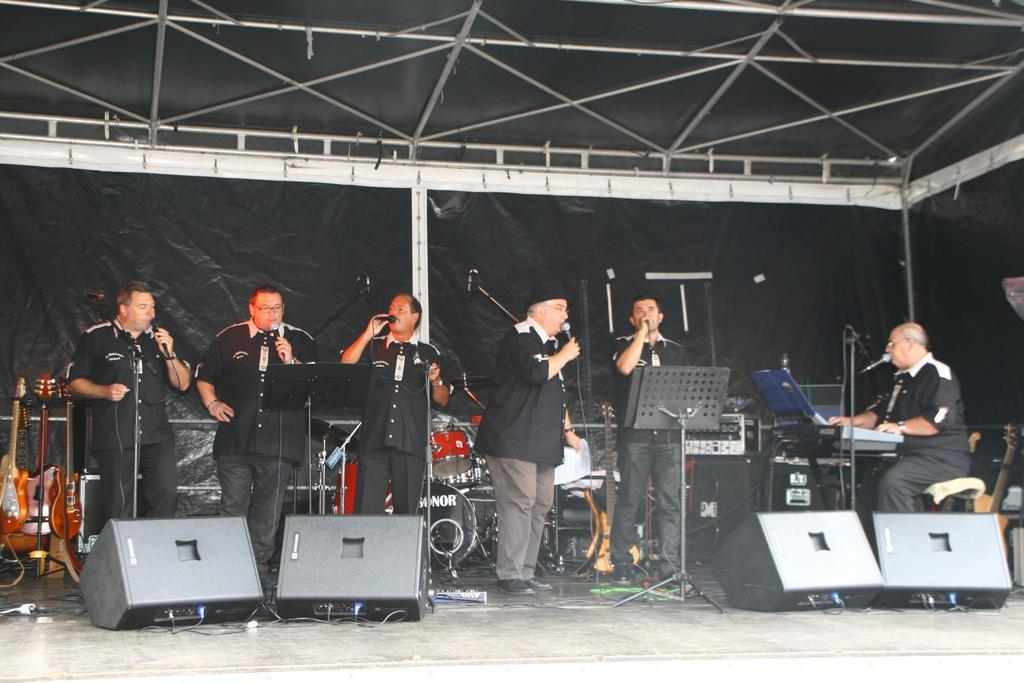What are the persons in the image doing? The persons in the image are standing and singing. What objects are the persons holding in their hands? The persons are holding microphones in their hands. What can be seen in the background of the image? There is a stand in the image. What musical instruments are present in the image? There are guitars in the image. How many fish can be seen swimming around the persons in the image? There are no fish visible in the image; it features a group of persons singing with guitars and microphones. What type of marble is used to decorate the stand in the image? There is no marble present in the image; the stand is not described in detail. 